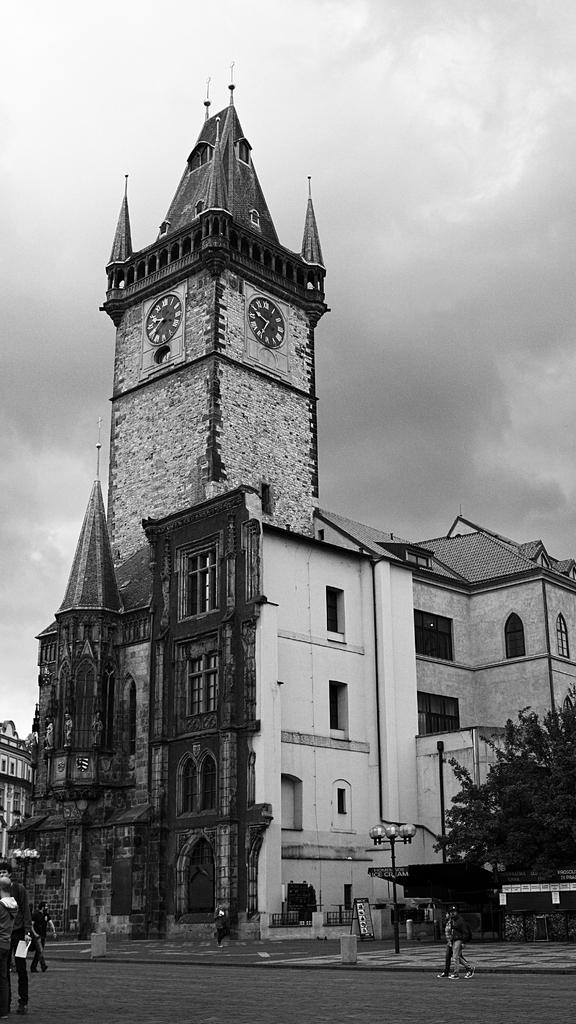What is the color scheme of the image? The image is in black and white. What can be seen on the ground in the image? There is a road in the image. What object is present near the road? There is a pole in the image. What type of vegetation is visible in the image? There is a tree in the image. What type of structure is present in the image? There is a building in the image. What is the condition of the sky in the image? The sky is covered with clouds. What type of needle is being used to copy the wool in the image? There is no needle or wool present in the image; it features a road, pole, tree, building, and a sky covered with clouds. 